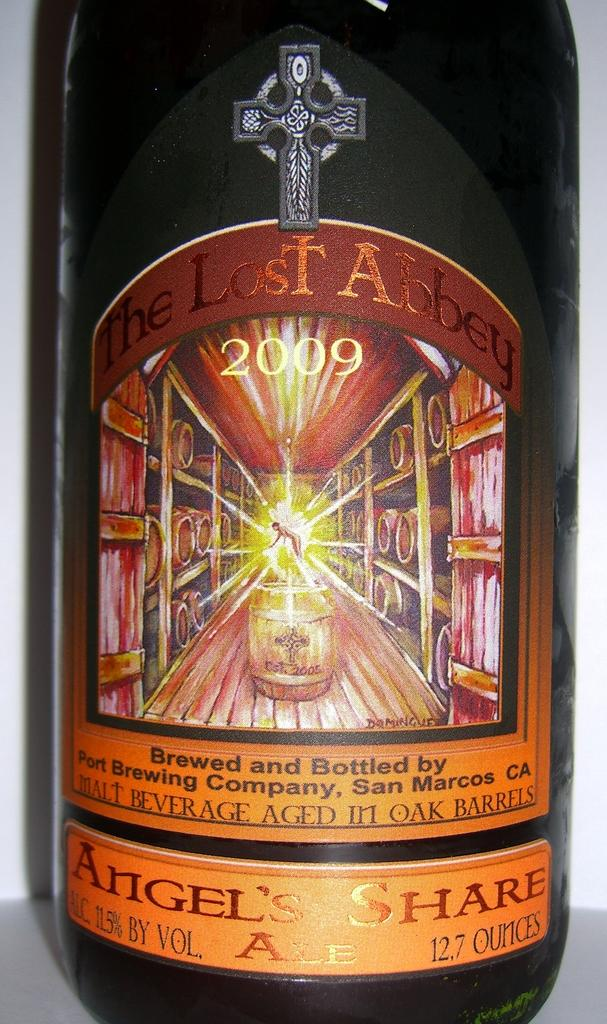<image>
Summarize the visual content of the image. A bottled brew that is labelled "The Lost Abbey". 